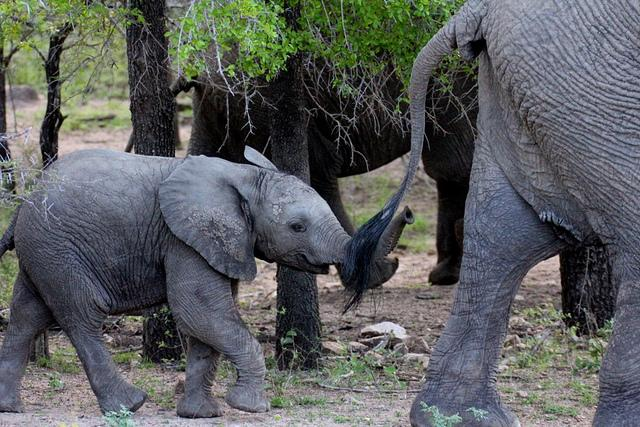Whos is the little elephant likely following? Please explain your reasoning. mother. It could be the other options too, but this is the most likely reason. 